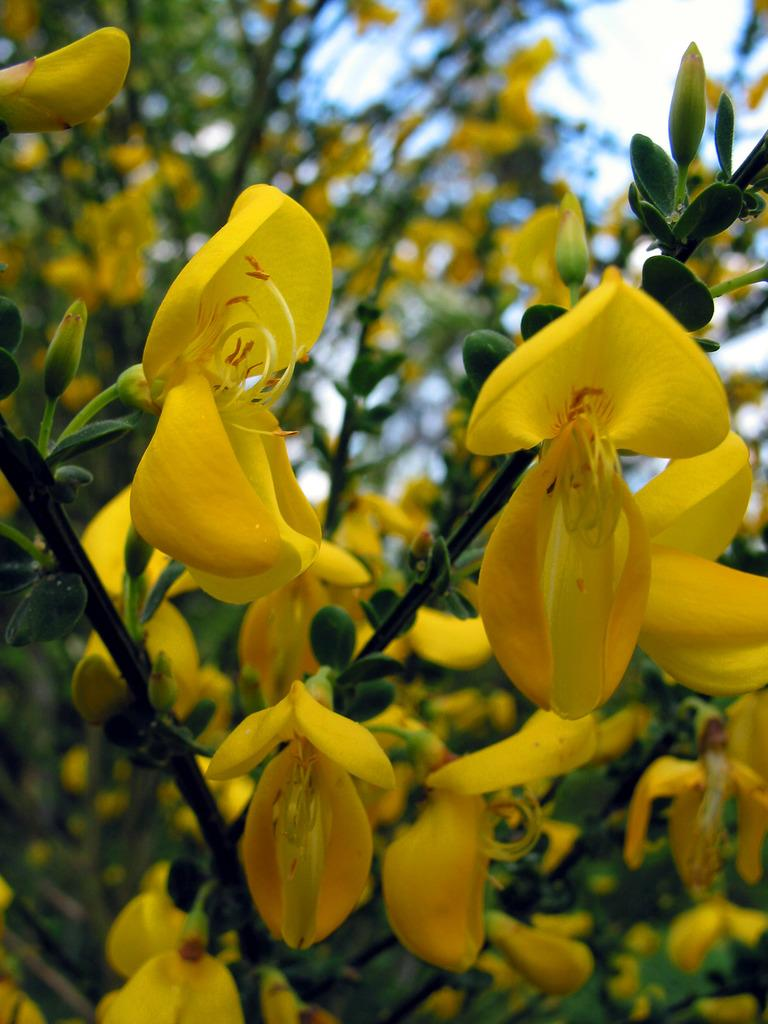What type of living organisms are present in the image? There are plants in the image. What specific features can be observed on the plants? The plants have flowers and buds. What type of wine is being poured from the bottle in the image? There is no wine or bottle present in the image; it features plants with flowers and buds. What color is the yarn used to knit the sweater in the image? There is no sweater or yarn present in the image; it features plants with flowers and buds. 